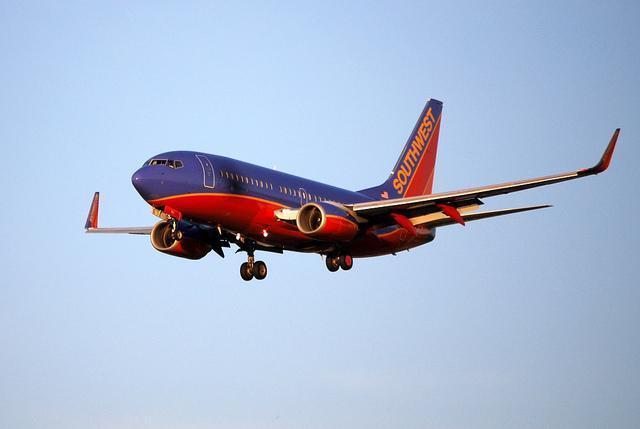How many people are in this picture?
Give a very brief answer. 0. 